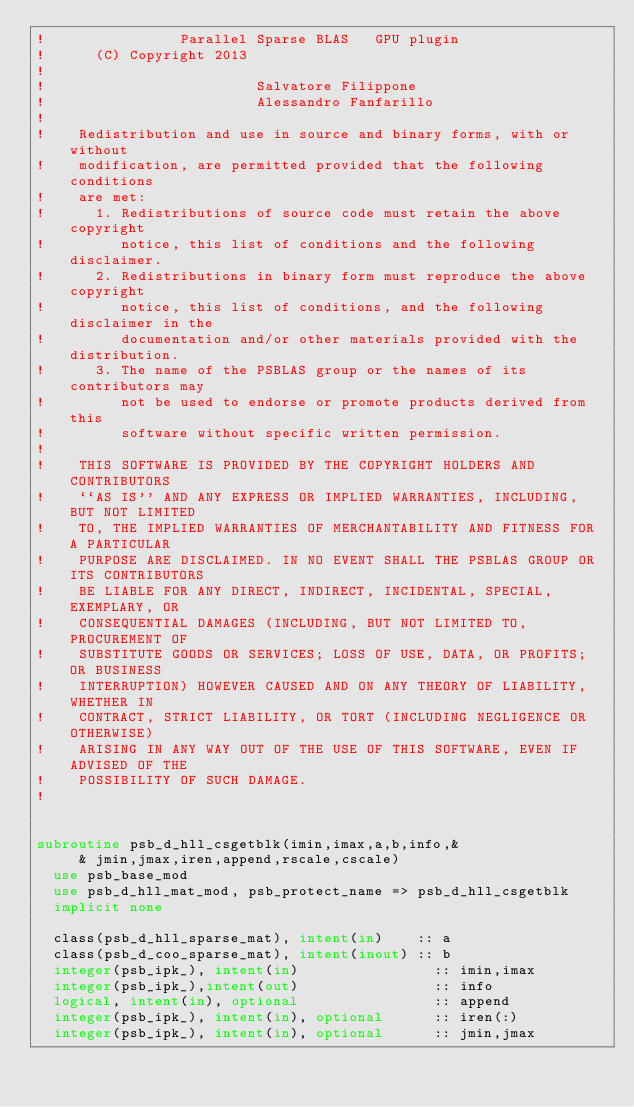<code> <loc_0><loc_0><loc_500><loc_500><_FORTRAN_>!                Parallel Sparse BLAS   GPU plugin 
!      (C) Copyright 2013
!  
!                         Salvatore Filippone
!                         Alessandro Fanfarillo
!   
!    Redistribution and use in source and binary forms, with or without
!    modification, are permitted provided that the following conditions
!    are met:
!      1. Redistributions of source code must retain the above copyright
!         notice, this list of conditions and the following disclaimer.
!      2. Redistributions in binary form must reproduce the above copyright
!         notice, this list of conditions, and the following disclaimer in the
!         documentation and/or other materials provided with the distribution.
!      3. The name of the PSBLAS group or the names of its contributors may
!         not be used to endorse or promote products derived from this
!         software without specific written permission.
!   
!    THIS SOFTWARE IS PROVIDED BY THE COPYRIGHT HOLDERS AND CONTRIBUTORS
!    ``AS IS'' AND ANY EXPRESS OR IMPLIED WARRANTIES, INCLUDING, BUT NOT LIMITED
!    TO, THE IMPLIED WARRANTIES OF MERCHANTABILITY AND FITNESS FOR A PARTICULAR
!    PURPOSE ARE DISCLAIMED. IN NO EVENT SHALL THE PSBLAS GROUP OR ITS CONTRIBUTORS
!    BE LIABLE FOR ANY DIRECT, INDIRECT, INCIDENTAL, SPECIAL, EXEMPLARY, OR
!    CONSEQUENTIAL DAMAGES (INCLUDING, BUT NOT LIMITED TO, PROCUREMENT OF
!    SUBSTITUTE GOODS OR SERVICES; LOSS OF USE, DATA, OR PROFITS; OR BUSINESS
!    INTERRUPTION) HOWEVER CAUSED AND ON ANY THEORY OF LIABILITY, WHETHER IN
!    CONTRACT, STRICT LIABILITY, OR TORT (INCLUDING NEGLIGENCE OR OTHERWISE)
!    ARISING IN ANY WAY OUT OF THE USE OF THIS SOFTWARE, EVEN IF ADVISED OF THE
!    POSSIBILITY OF SUCH DAMAGE.
!   
  

subroutine psb_d_hll_csgetblk(imin,imax,a,b,info,&
     & jmin,jmax,iren,append,rscale,cscale)
  use psb_base_mod
  use psb_d_hll_mat_mod, psb_protect_name => psb_d_hll_csgetblk
  implicit none

  class(psb_d_hll_sparse_mat), intent(in)    :: a
  class(psb_d_coo_sparse_mat), intent(inout) :: b
  integer(psb_ipk_), intent(in)                :: imin,imax
  integer(psb_ipk_),intent(out)                :: info
  logical, intent(in), optional                :: append
  integer(psb_ipk_), intent(in), optional      :: iren(:)
  integer(psb_ipk_), intent(in), optional      :: jmin,jmax</code> 